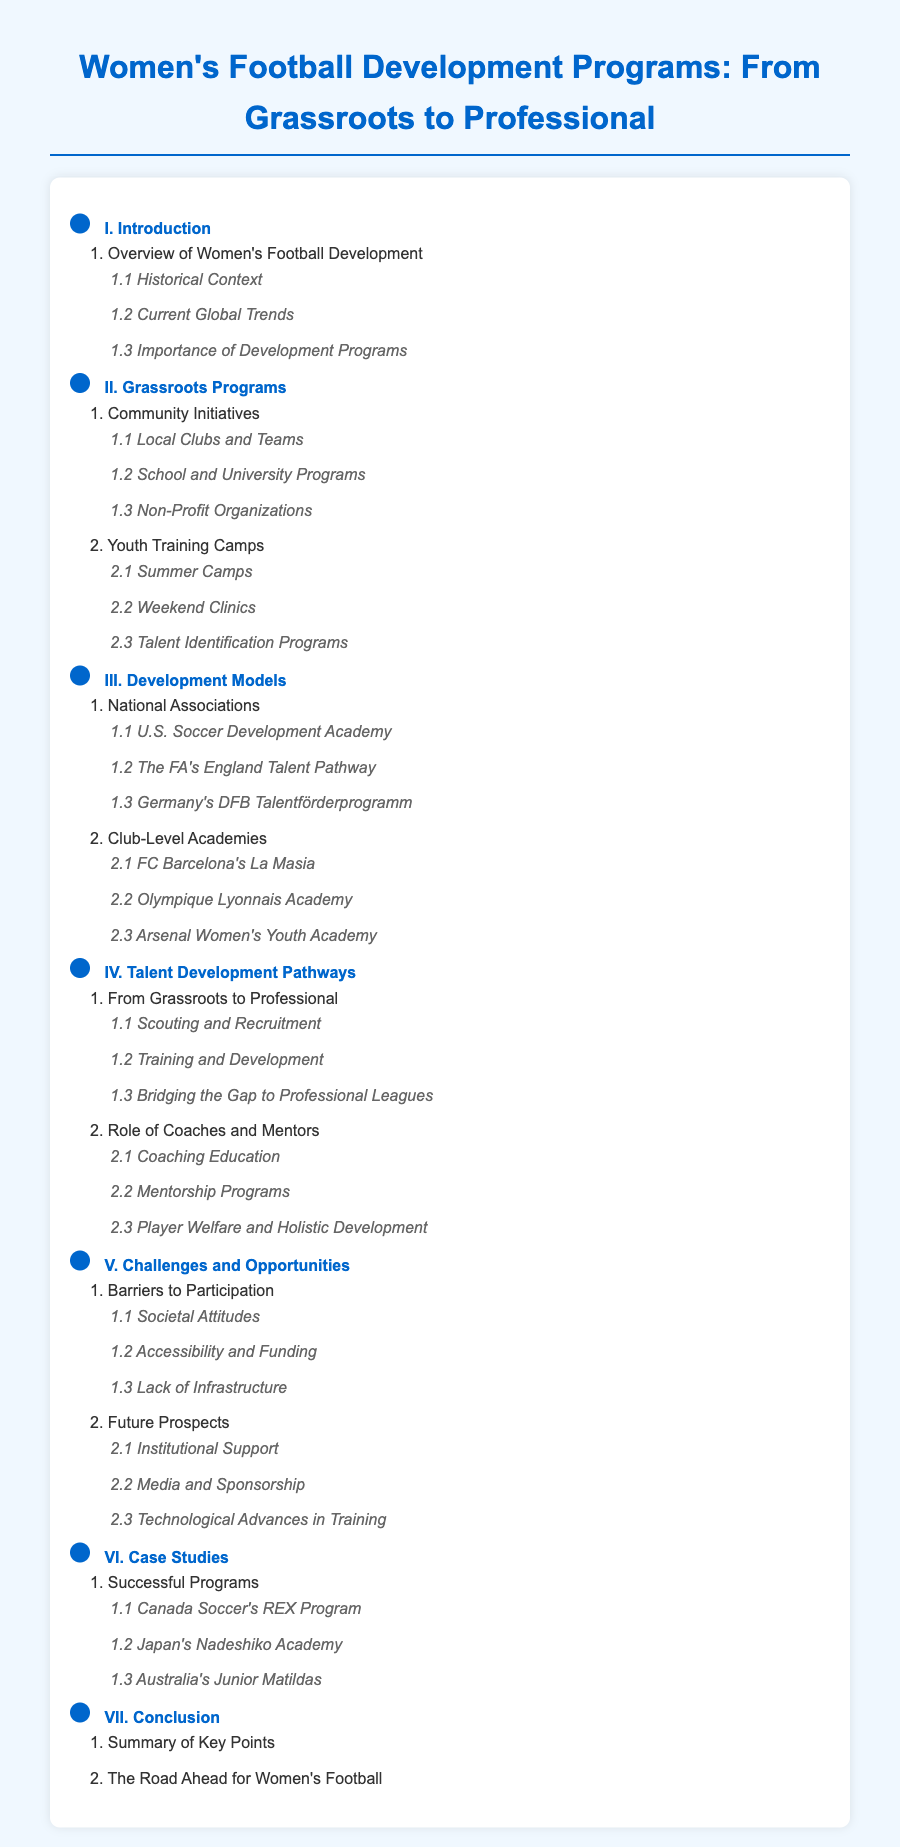What are the key sections in the document? The key sections are listed as I, II, III, IV, V, VI, and VII, focusing on various aspects of women's football development.
Answer: I, II, III, IV, V, VI, VII How many subsections are under Grassroots Programs? The section II contains two subsections, detailed in the document as Community Initiatives and Youth Training Camps.
Answer: 2 What is a notable program under Successful Programs? The section VI lists several successful programs, including Canada Soccer's REX Program.
Answer: Canada Soccer's REX Program What is one challenge mentioned in the Challenges and Opportunities section? Under section V, the document highlights Barriers to Participation as a significant challenge.
Answer: Barriers to Participation Which association's development model is specifically mentioned in Development Models? The Development Models section contains multiple associations, including U.S. Soccer Development Academy.
Answer: U.S. Soccer Development Academy What is the focus of the Talent Development Pathways section? This section emphasizes the journey from grassroots levels to professional environments as well as the role of coaches.
Answer: From Grassroots to Professional How many programs are listed under Case Studies? There is one subsection under Case Studies discussing Successful Programs, which includes three specific examples.
Answer: 3 